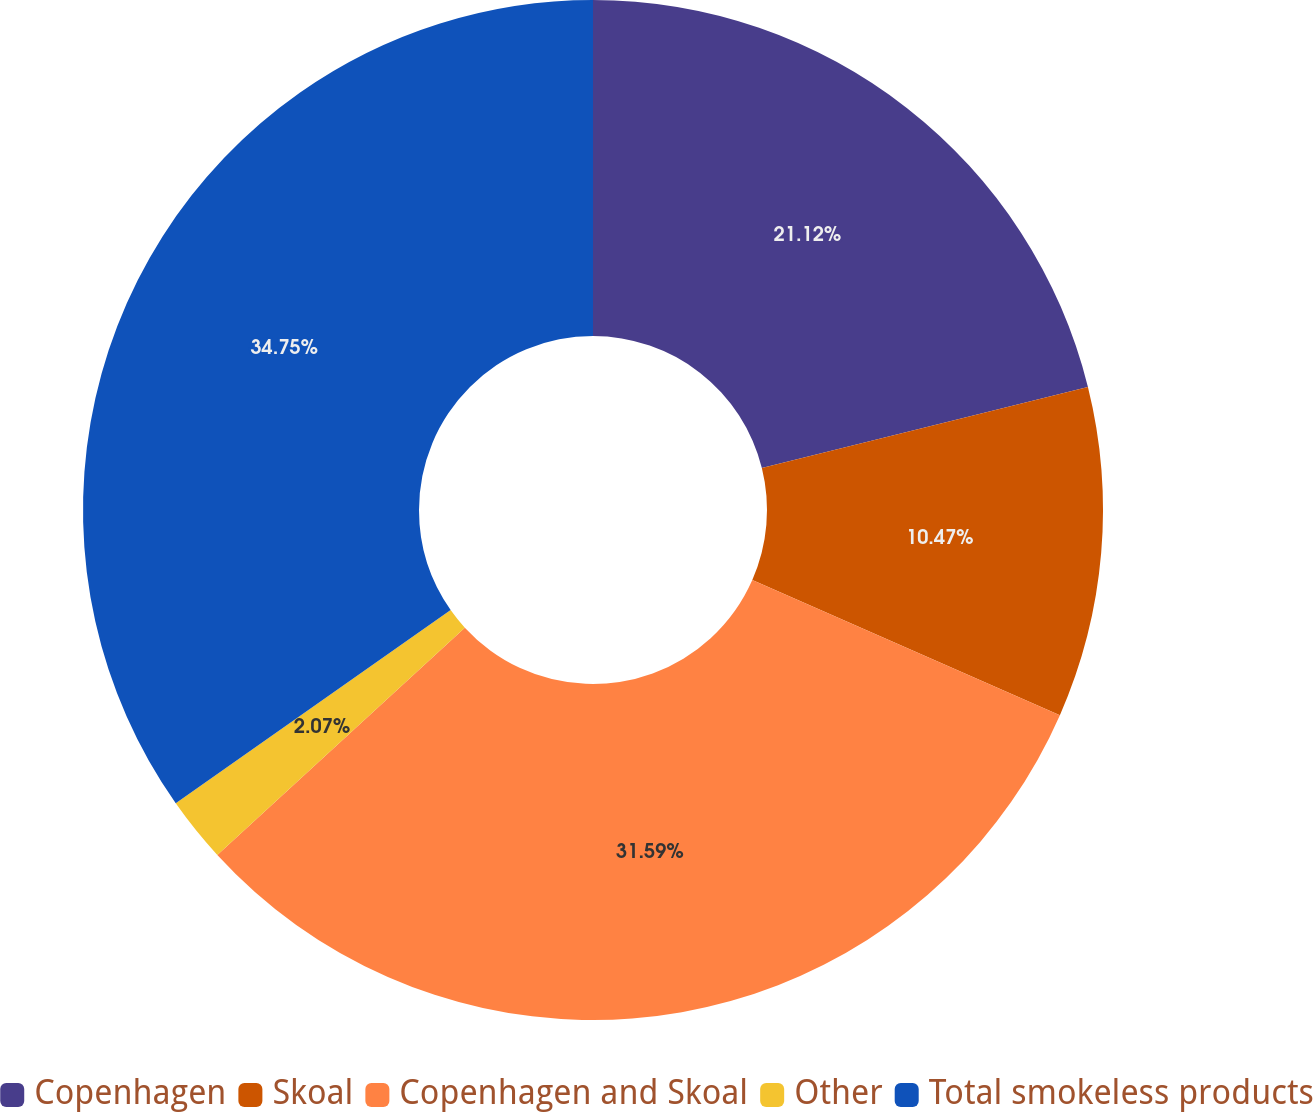Convert chart to OTSL. <chart><loc_0><loc_0><loc_500><loc_500><pie_chart><fcel>Copenhagen<fcel>Skoal<fcel>Copenhagen and Skoal<fcel>Other<fcel>Total smokeless products<nl><fcel>21.12%<fcel>10.47%<fcel>31.59%<fcel>2.07%<fcel>34.75%<nl></chart> 